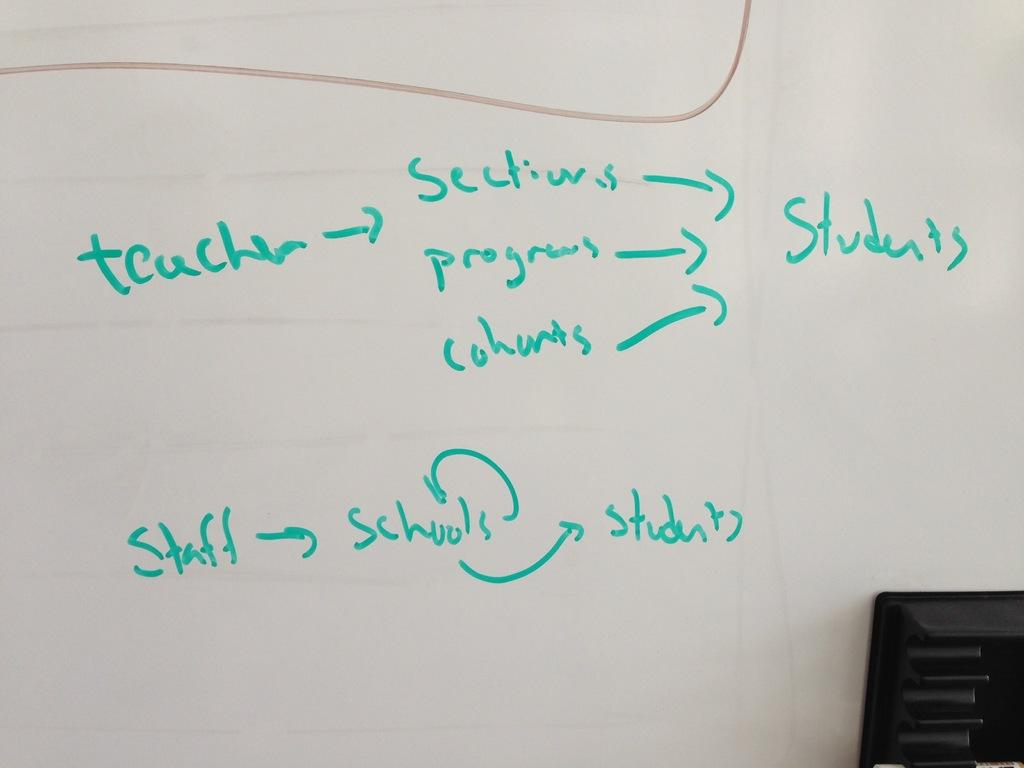<image>
Relay a brief, clear account of the picture shown. A diagram in green addresses teaching and students. 